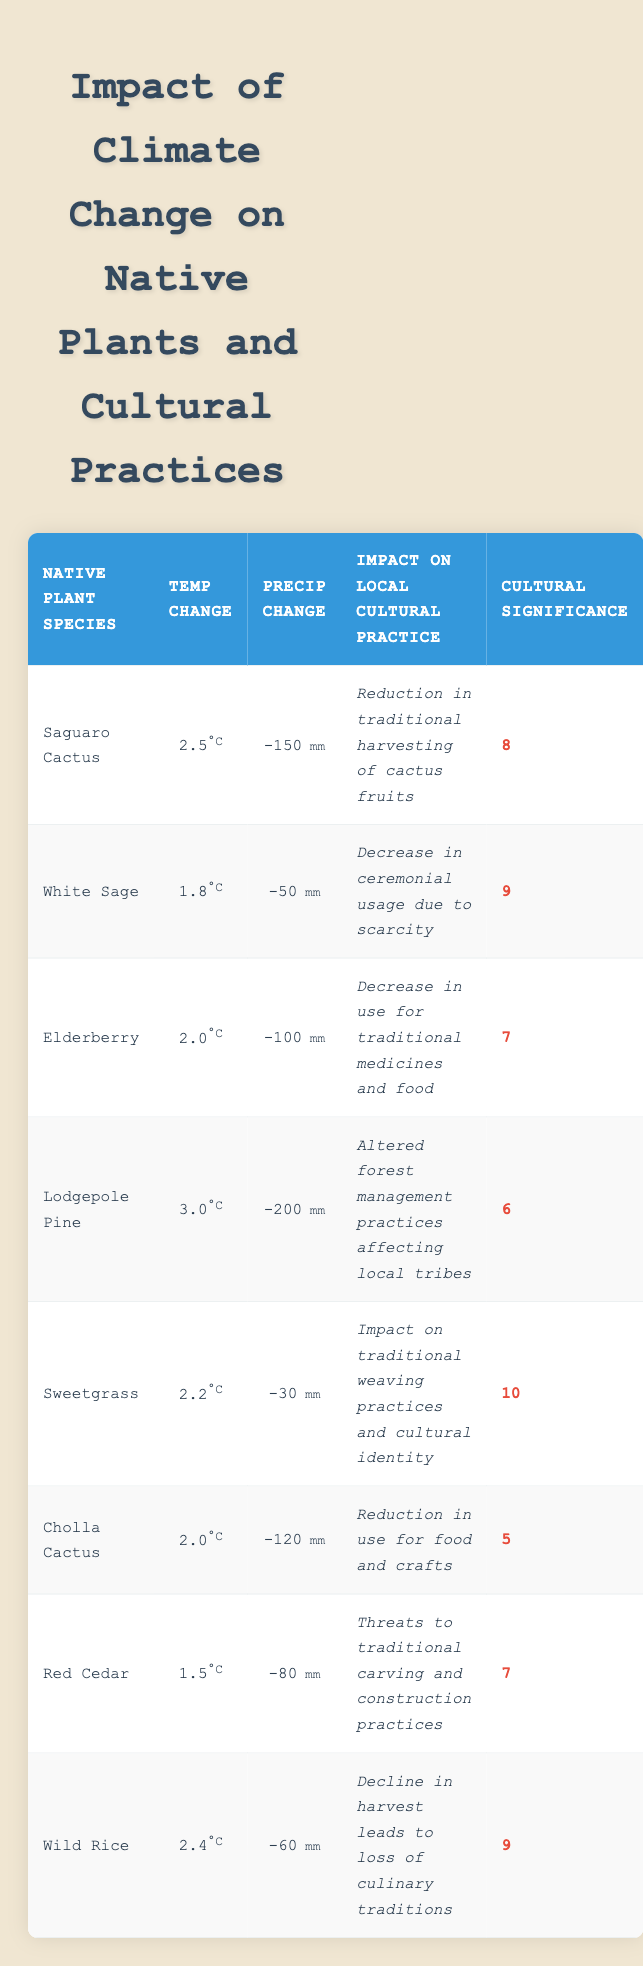What is the impact on local cultural practice for Sweetgrass? According to the table, Sweetgrass is affected by climate change, leading to an impact on traditional weaving practices and cultural identity.
Answer: Impact on traditional weaving practices and cultural identity Which native plant species has the highest cultural significance score? By reviewing the cultural significance scores in the table, Sweetgrass has the highest score of 10.
Answer: Sweetgrass What is the temperature change associated with Lodgepole Pine? The table indicates that the average temperature change for Lodgepole Pine is 3.0 degrees Celsius.
Answer: 3.0 How many native plant species have a cultural significance score of 7? The table lists two species—Elderberry and Red Cedar—that have a cultural significance score of 7.
Answer: 2 What is the average precipitation change for the plants categorized with a cultural significance score of 9? For the plants with a cultural significance score of 9, the species are White Sage and Wild Rice. Their precipitation changes are -50 mm and -60 mm, respectively. The average is (-50 + -60) / 2 = -55 mm.
Answer: -55 mm Is there any native plant species that has both low cultural significance and high temperature change? Reviewing the table, Cholla Cactus has a cultural significance score of 5 (low) and a temperature change of 2.0 degrees Celsius (moderate). Therefore, the statement is false as it isn’t a high temperature change species.
Answer: No What is the difference in average precipitation change between Saguaro Cactus and Sweetgrass? The data shows that Saguaro Cactus has a precipitation change of -150 mm and Sweetgrass has -30 mm. The difference is calculated as -150 - (-30) = -120 mm.
Answer: -120 mm Which two native plants have the closest temperature changes among the listed species? Looking through the table, Elderberry (2.0) and Cholla Cactus (2.0) both have a temperature change of 2.0 degrees Celsius, which shows they are equal in value.
Answer: Elderberry and Cholla Cactus 